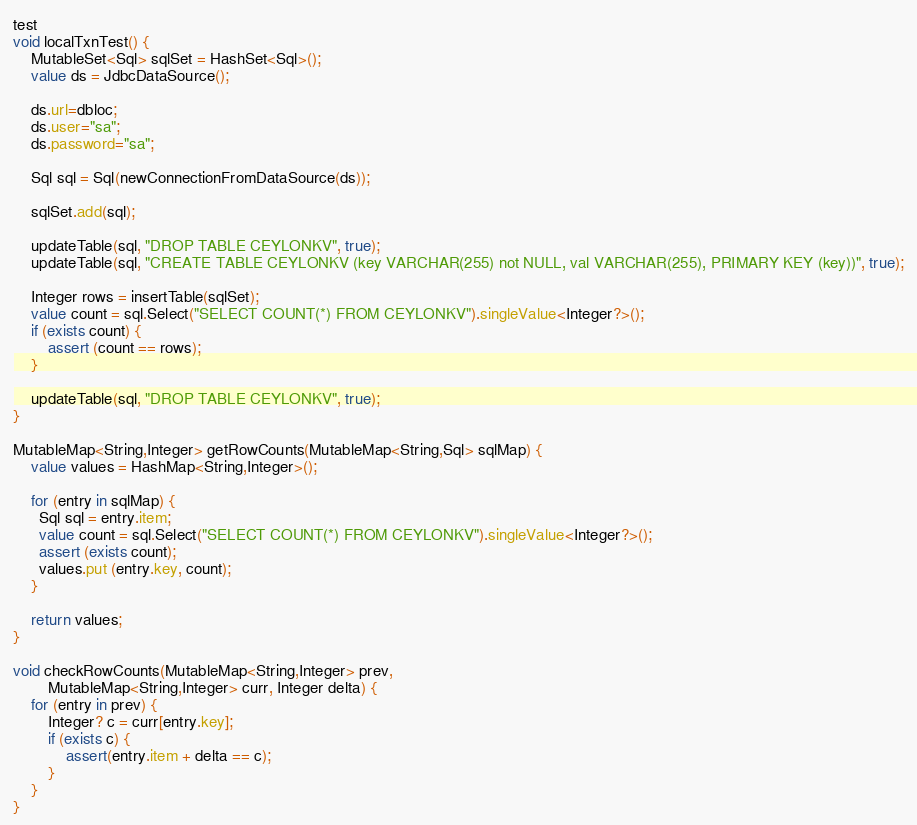Convert code to text. <code><loc_0><loc_0><loc_500><loc_500><_Ceylon_>
test
void localTxnTest() {
    MutableSet<Sql> sqlSet = HashSet<Sql>();
    value ds = JdbcDataSource();

    ds.url=dbloc;
    ds.user="sa";
    ds.password="sa";

    Sql sql = Sql(newConnectionFromDataSource(ds));

    sqlSet.add(sql);

    updateTable(sql, "DROP TABLE CEYLONKV", true);
    updateTable(sql, "CREATE TABLE CEYLONKV (key VARCHAR(255) not NULL, val VARCHAR(255), PRIMARY KEY (key))", true);

    Integer rows = insertTable(sqlSet);
	value count = sql.Select("SELECT COUNT(*) FROM CEYLONKV").singleValue<Integer?>();
    if (exists count) {
        assert (count == rows);
    }

    updateTable(sql, "DROP TABLE CEYLONKV", true);
}

MutableMap<String,Integer> getRowCounts(MutableMap<String,Sql> sqlMap) {
    value values = HashMap<String,Integer>();

    for (entry in sqlMap) {
      Sql sql = entry.item;
	  value count = sql.Select("SELECT COUNT(*) FROM CEYLONKV").singleValue<Integer?>();
      assert (exists count);
      values.put (entry.key, count);
    }

    return values;
}

void checkRowCounts(MutableMap<String,Integer> prev, 
        MutableMap<String,Integer> curr, Integer delta) {
    for (entry in prev) {
        Integer? c = curr[entry.key];
        if (exists c) {
            assert(entry.item + delta == c);
        } 
    }
}

</code> 